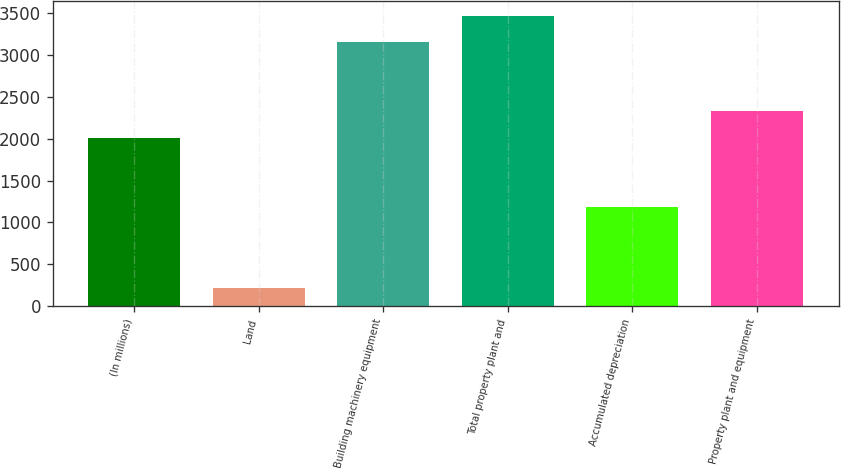Convert chart to OTSL. <chart><loc_0><loc_0><loc_500><loc_500><bar_chart><fcel>(In millions)<fcel>Land<fcel>Building machinery equipment<fcel>Total property plant and<fcel>Accumulated depreciation<fcel>Property plant and equipment<nl><fcel>2014<fcel>221<fcel>3155<fcel>3470.5<fcel>1180<fcel>2329.5<nl></chart> 